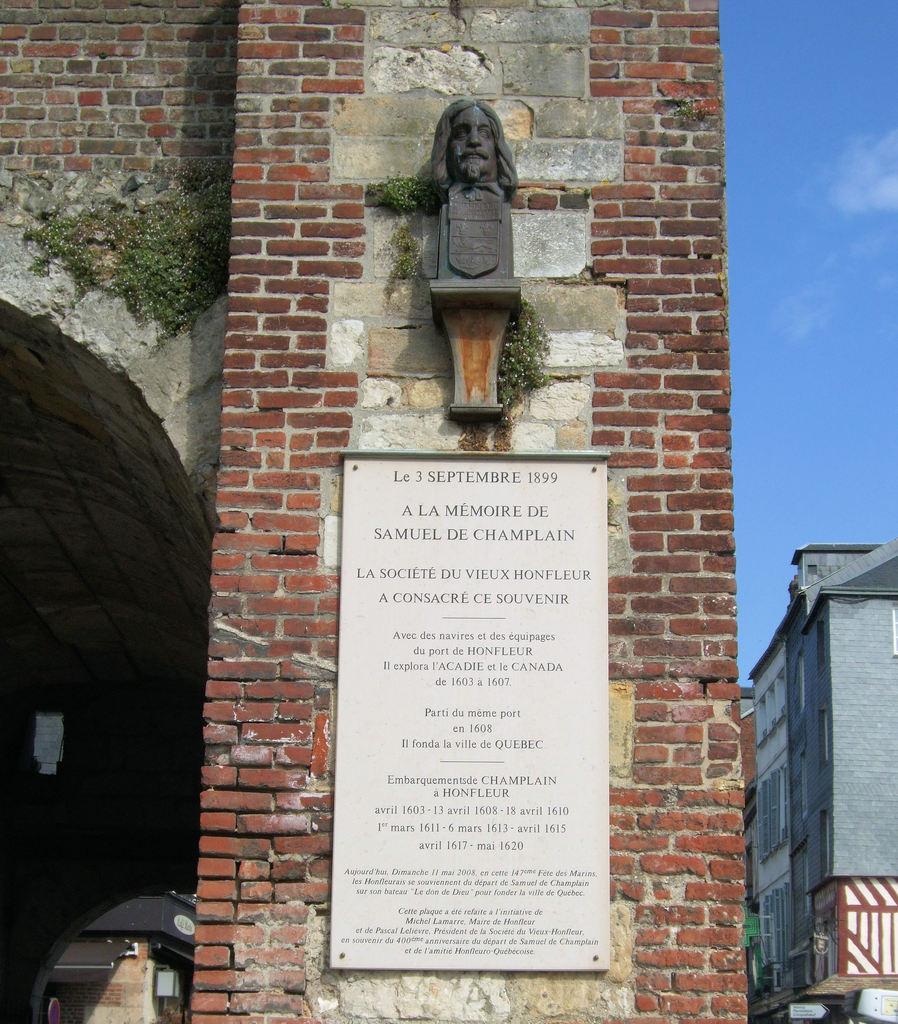Please provide a concise description of this image. In this picture we can observe a white color board fixed to the wall. We can observe a head of a person fixed to the wall. This wall is in red color. On the right side there are buildings. In the background there is a sky. 